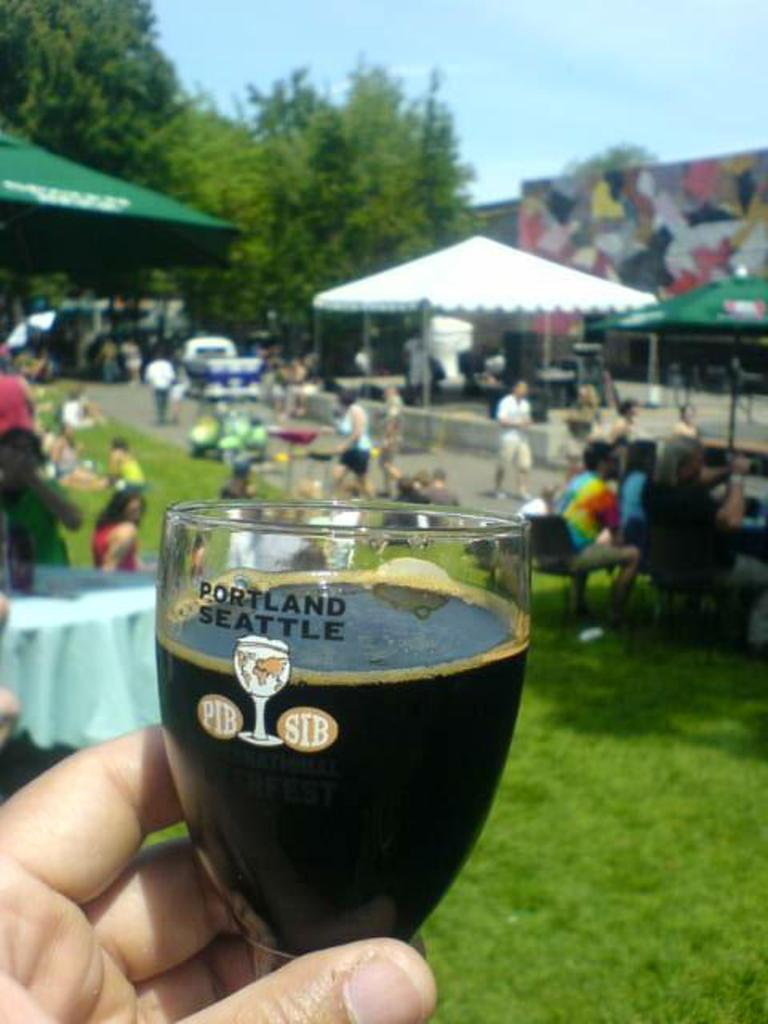<image>
Create a compact narrative representing the image presented. The persons beer glass is from Portland Seattle 